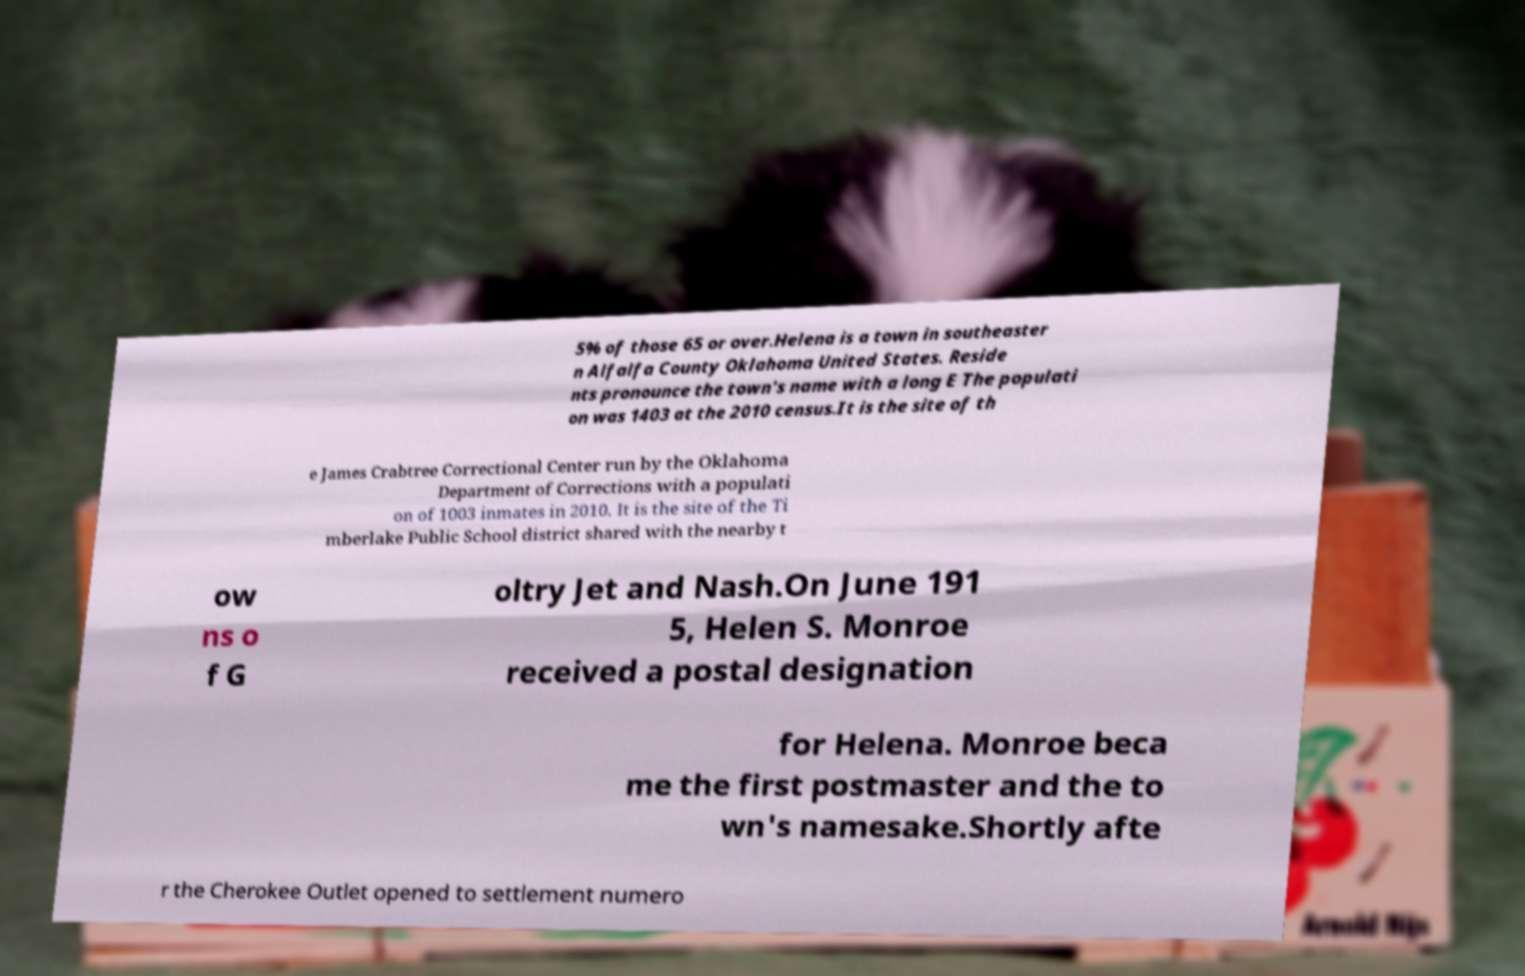Can you accurately transcribe the text from the provided image for me? 5% of those 65 or over.Helena is a town in southeaster n Alfalfa County Oklahoma United States. Reside nts pronounce the town's name with a long E The populati on was 1403 at the 2010 census.It is the site of th e James Crabtree Correctional Center run by the Oklahoma Department of Corrections with a populati on of 1003 inmates in 2010. It is the site of the Ti mberlake Public School district shared with the nearby t ow ns o f G oltry Jet and Nash.On June 191 5, Helen S. Monroe received a postal designation for Helena. Monroe beca me the first postmaster and the to wn's namesake.Shortly afte r the Cherokee Outlet opened to settlement numero 